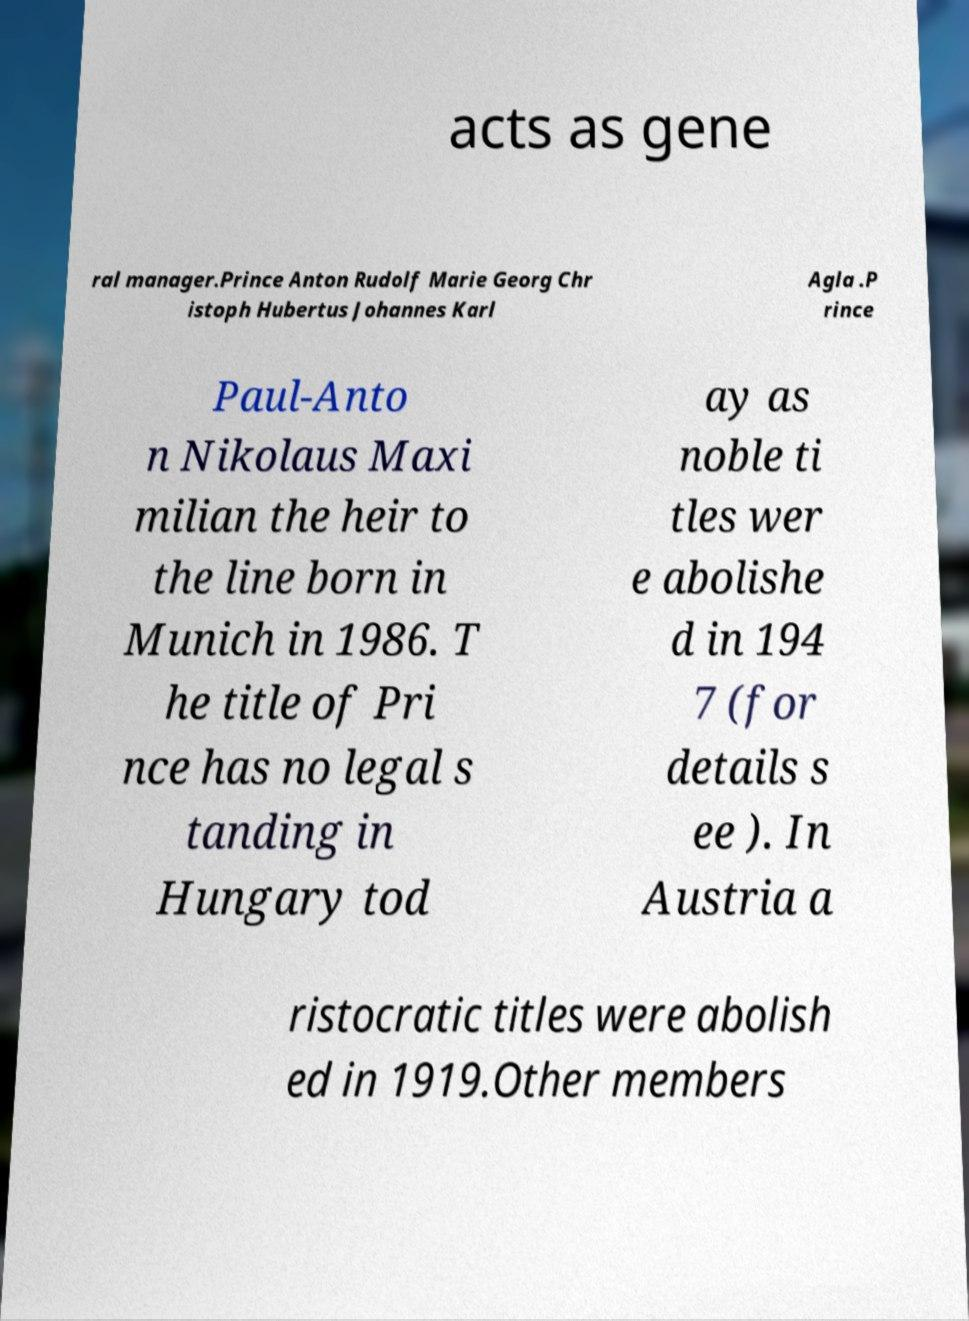Can you read and provide the text displayed in the image?This photo seems to have some interesting text. Can you extract and type it out for me? acts as gene ral manager.Prince Anton Rudolf Marie Georg Chr istoph Hubertus Johannes Karl Agla .P rince Paul-Anto n Nikolaus Maxi milian the heir to the line born in Munich in 1986. T he title of Pri nce has no legal s tanding in Hungary tod ay as noble ti tles wer e abolishe d in 194 7 (for details s ee ). In Austria a ristocratic titles were abolish ed in 1919.Other members 